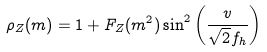Convert formula to latex. <formula><loc_0><loc_0><loc_500><loc_500>\rho _ { Z } ( m ) = 1 + F _ { Z } ( m ^ { 2 } ) \sin ^ { 2 } \left ( \frac { v } { \sqrt { 2 } f _ { h } } \right )</formula> 